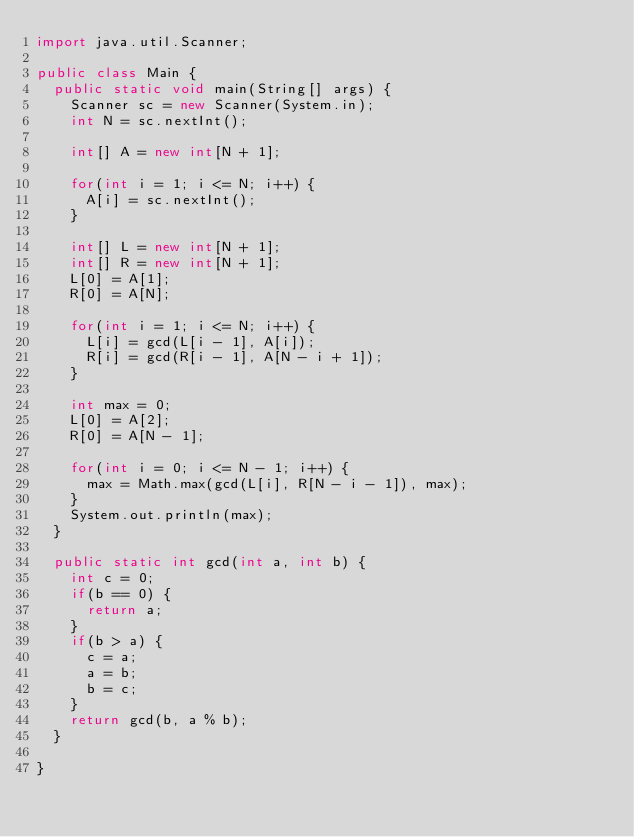Convert code to text. <code><loc_0><loc_0><loc_500><loc_500><_Java_>import java.util.Scanner;

public class Main {
	public static void main(String[] args) {
		Scanner sc = new Scanner(System.in);
		int N = sc.nextInt();
		
		int[] A = new int[N + 1];
		
		for(int i = 1; i <= N; i++) {
			A[i] = sc.nextInt();
		}
		
		int[] L = new int[N + 1];
		int[] R = new int[N + 1];
		L[0] = A[1];
		R[0] = A[N];
		
		for(int i = 1; i <= N; i++) {
			L[i] = gcd(L[i - 1], A[i]);
			R[i] = gcd(R[i - 1], A[N - i + 1]);
		}
		
		int max = 0;
		L[0] = A[2];
		R[0] = A[N - 1];
		
		for(int i = 0; i <= N - 1; i++) {
			max = Math.max(gcd(L[i], R[N - i - 1]), max);
		}
		System.out.println(max);
	}
	
	public static int gcd(int a, int b) {
		int c = 0;
		if(b == 0) {
			return a;
		}
		if(b > a) {
			c = a;
			a = b;
			b = c;
		}
		return gcd(b, a % b);
	}
	
}
</code> 